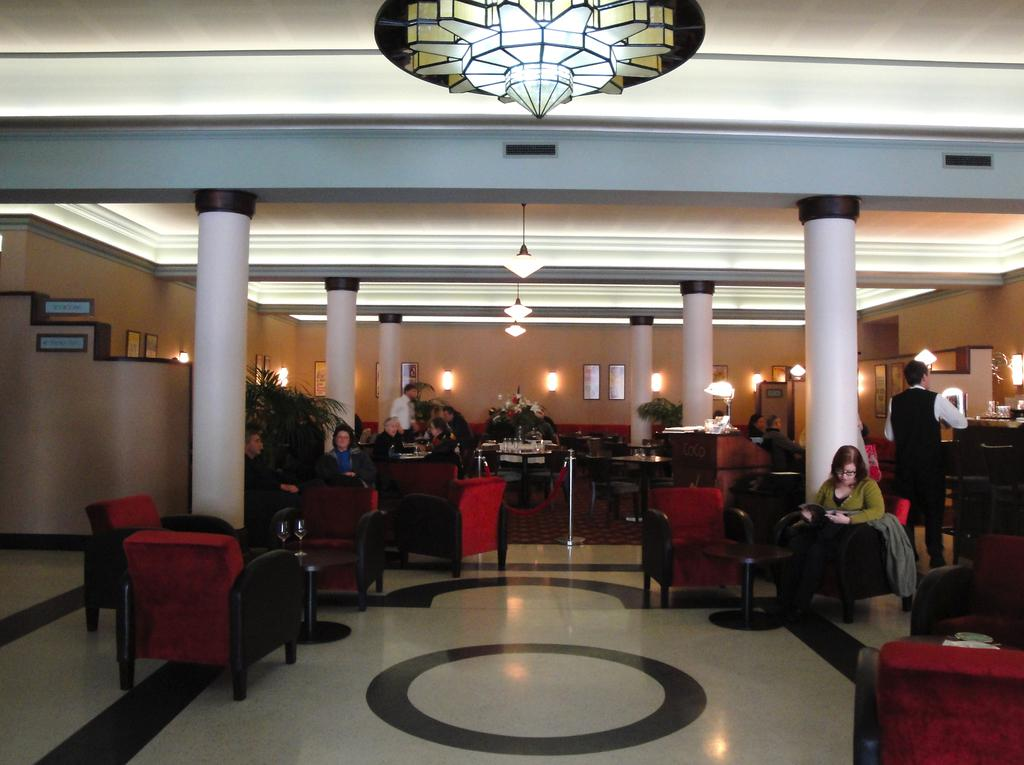What type of furniture is present in the image? There are chairs in the image. What are the people in the image doing? There are people seated on the chairs. Can you describe the position of the man in the image? There is a man standing in the image. What type of pot is the man holding in the image? There is no pot present in the image; the man is standing without holding anything. What is the man using to hold his arrows in the image? There is no quiver present in the image, nor is the man holding any arrows. 